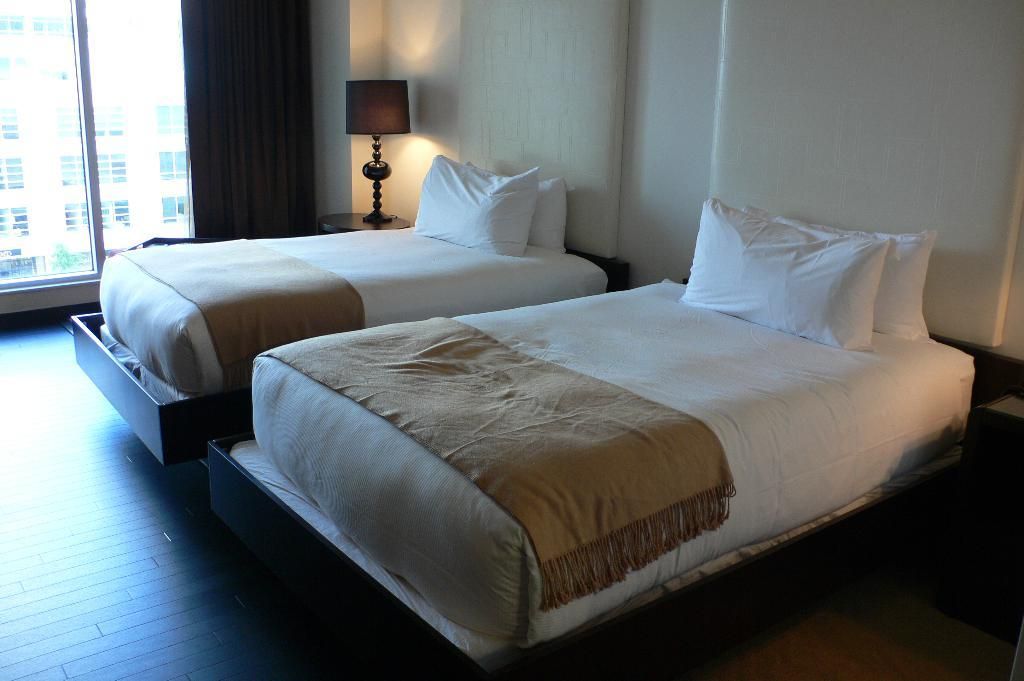What can be seen in the image that allows light to enter the room? There is a window in the image that allows light to enter the room. What color is the wall that is visible in the image? The wall in the image is white in color. What is the source of artificial light in the image? There is a lamp in the image that provides artificial light. How many beds are present in the image? There are two beds in the image. What color are the pillows on the beds? The pillows on the beds are white in color. How does the kitty use the transport in the image? There is no kitty or transport present in the image. 